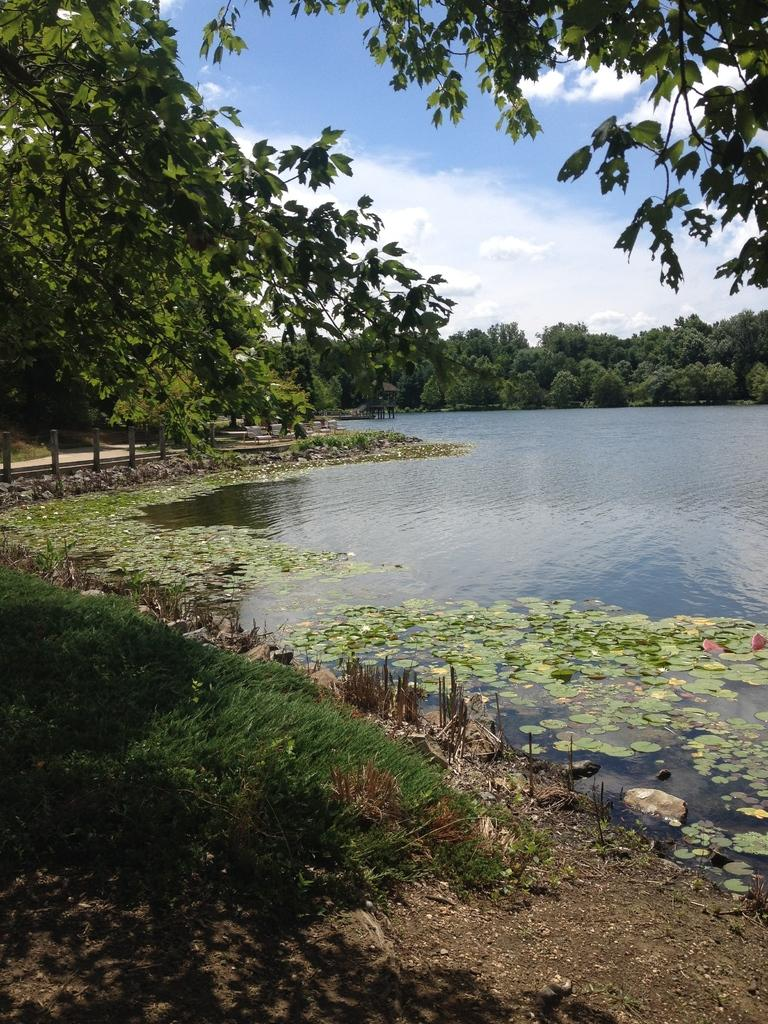What type of vegetation is present in the image? There are many trees in the image. What type of ground cover can be seen at the bottom of the image? There is grass visible at the bottom of the image. What is located on the left side of the image? There is water on the left side of the image. Can you describe the background of the image? There are many trees in the background of the image. What is visible at the top of the image? The sky is visible at the top of the image. What can be seen in the sky? Clouds are present in the sky. What type of fruit is hanging from the trees in the image? There is no fruit visible in the image; only trees, grass, water, and clouds are present. Can you see a baseball game being played in the image? There is no baseball game or any reference to sports in the image. 